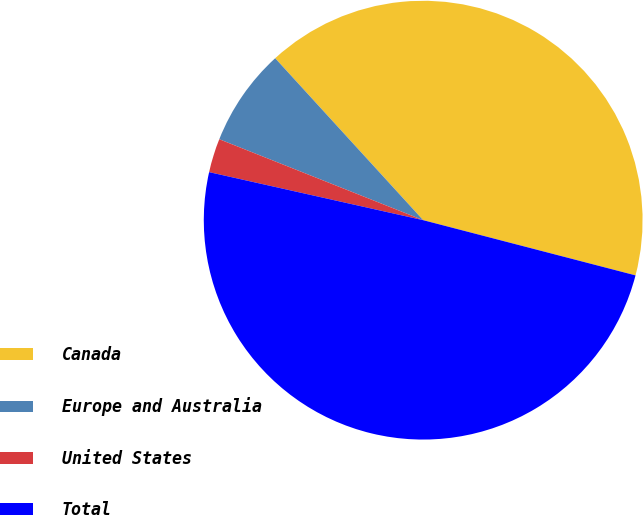Convert chart to OTSL. <chart><loc_0><loc_0><loc_500><loc_500><pie_chart><fcel>Canada<fcel>Europe and Australia<fcel>United States<fcel>Total<nl><fcel>40.83%<fcel>7.2%<fcel>2.5%<fcel>49.46%<nl></chart> 